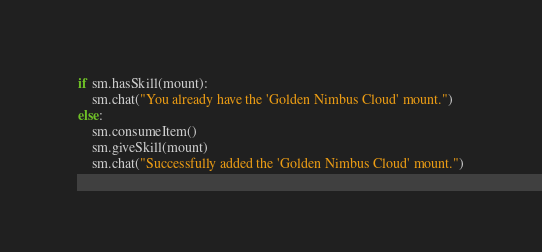Convert code to text. <code><loc_0><loc_0><loc_500><loc_500><_Python_>if sm.hasSkill(mount):
    sm.chat("You already have the 'Golden Nimbus Cloud' mount.")
else:
    sm.consumeItem()
    sm.giveSkill(mount)
    sm.chat("Successfully added the 'Golden Nimbus Cloud' mount.")
</code> 